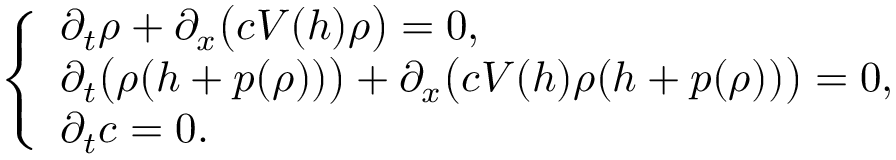<formula> <loc_0><loc_0><loc_500><loc_500>\left \{ \begin{array} { l l } { \partial _ { t } \rho + \partial _ { x } \left ( c V ( h ) \rho \right ) = 0 , } \\ { \partial _ { t } \left ( \rho ( h + p ( \rho ) ) \right ) + \partial _ { x } \left ( c V ( h ) \rho ( h + p ( \rho ) ) \right ) = 0 , } \\ { \partial _ { t } c = 0 . } \end{array}</formula> 